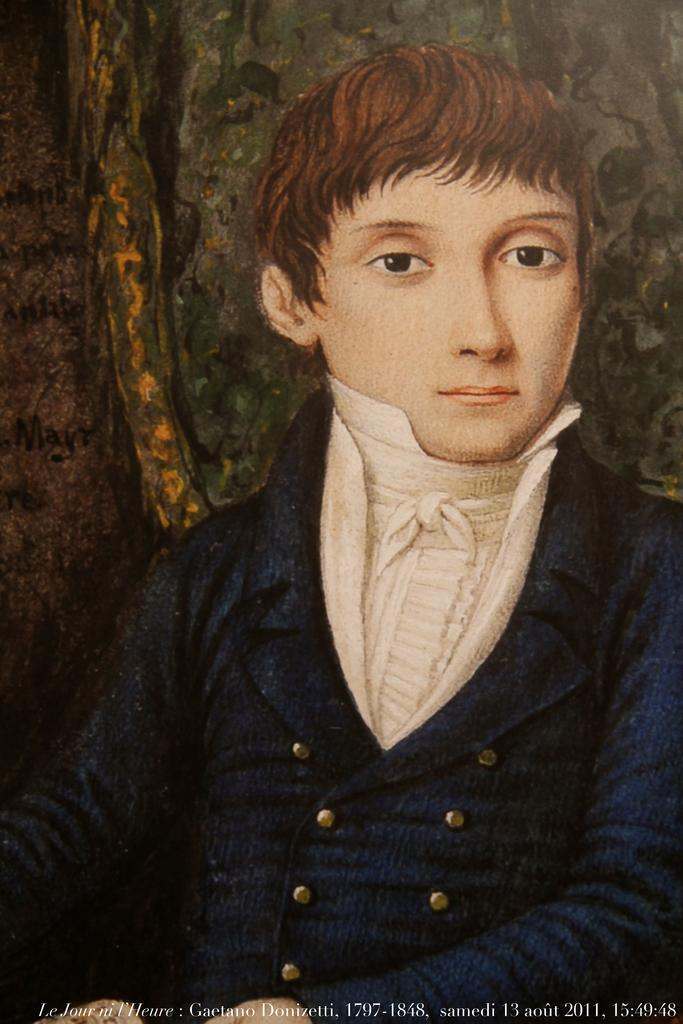What is the main subject of the image? There is a picture of a person in the image. Is there any text associated with the image? Yes, there is text at the bottom of the image. What type of pancake is being served to the doll in the image? There is no doll or pancake present in the image; it only features a picture of a person and text at the bottom. 